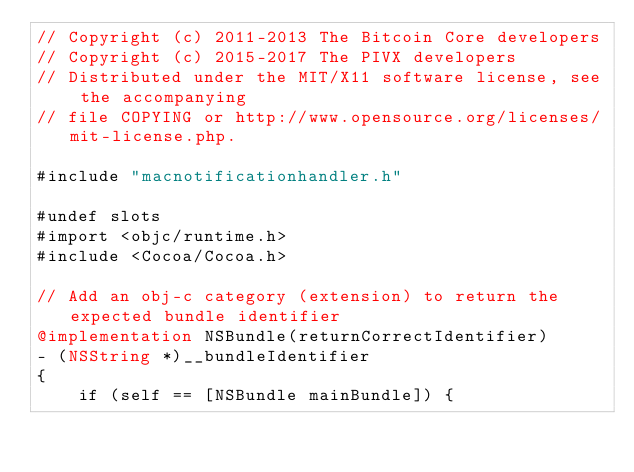<code> <loc_0><loc_0><loc_500><loc_500><_ObjectiveC_>// Copyright (c) 2011-2013 The Bitcoin Core developers
// Copyright (c) 2015-2017 The PIVX developers
// Distributed under the MIT/X11 software license, see the accompanying
// file COPYING or http://www.opensource.org/licenses/mit-license.php.

#include "macnotificationhandler.h"

#undef slots
#import <objc/runtime.h>
#include <Cocoa/Cocoa.h>

// Add an obj-c category (extension) to return the expected bundle identifier
@implementation NSBundle(returnCorrectIdentifier)
- (NSString *)__bundleIdentifier
{
    if (self == [NSBundle mainBundle]) {</code> 